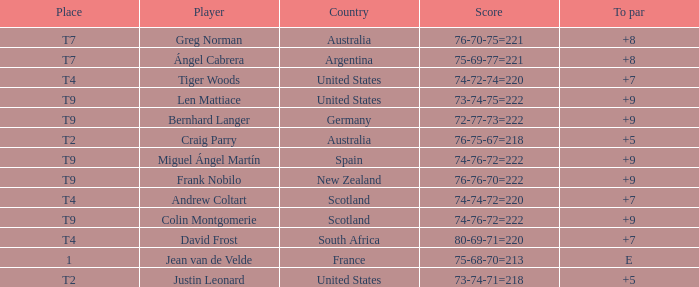Which player from Scotland has a To Par score of +7? Andrew Coltart. 